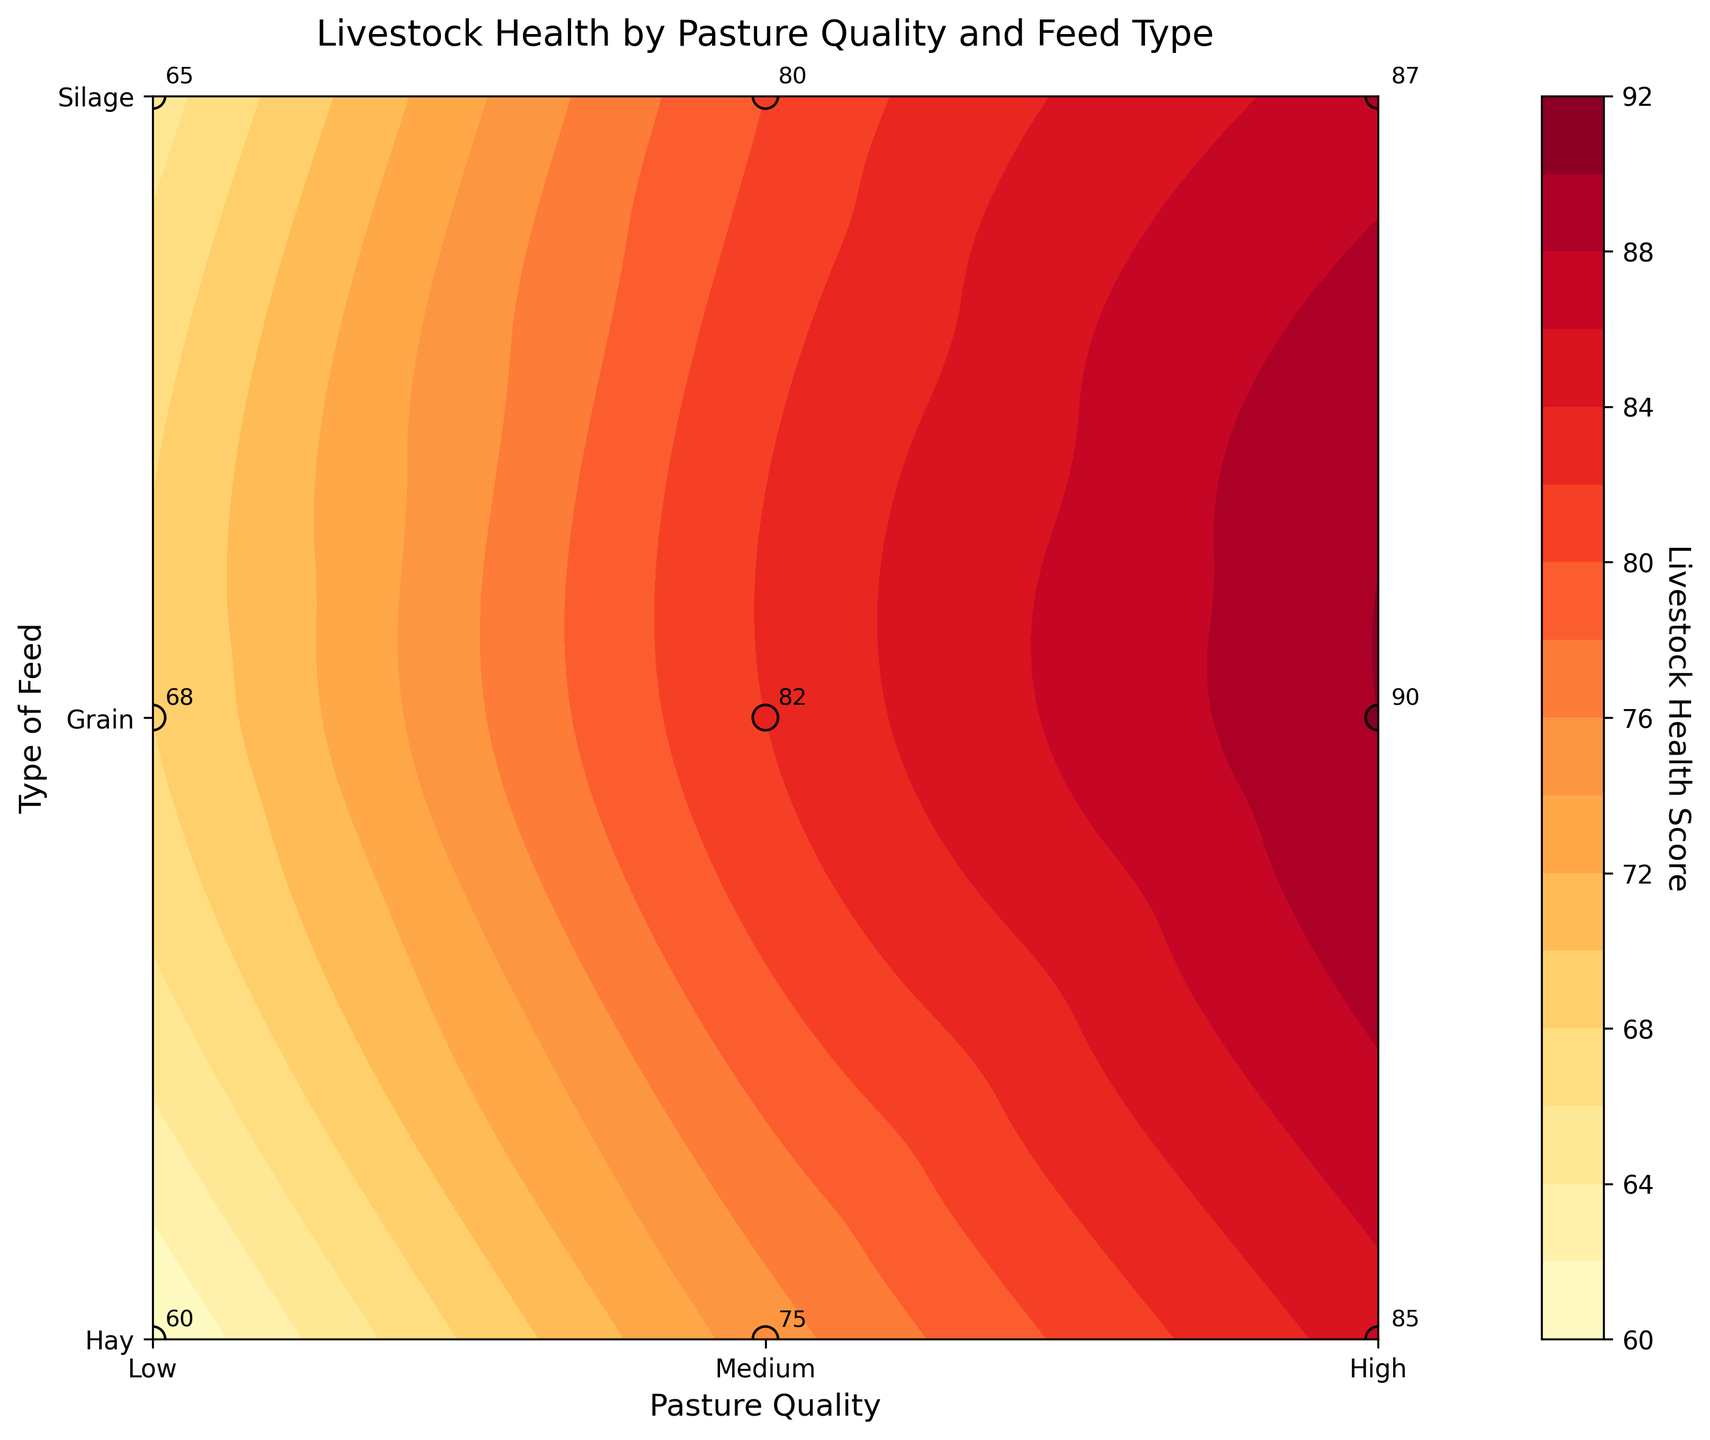What is the title of the figure? The title is located at the top of the figure. It provides a summary of what the figure is about.
Answer: Livestock Health by Pasture Quality and Feed Type Which axis represents the types of feed? The y-axis lists the types of feed used for the livestock.
Answer: Y-axis Which feed type and pasture quality combination achieved the highest livestock health score? The highest score is marked with the darkest color on the color gradient and is annotated with the value on the plot. The score for "High" pasture quality and "Grain" feed is 90, which is the highest.
Answer: High pasture quality and Grain feed What is the livestock health score for Medium pasture quality and Hay feed? Find the point where "Medium" pasture quality intersects with "Hay" feed, and read the annotated score value.
Answer: 75 Which pasture quality category has the highest average livestock health score across all feed types? Calculate the average score for "Low," "Medium," and "High" pasture qualities. "Low" has (60+68+65)/3=64.33, "Medium" has (75+82+80)/3=79, "High" has (85+90+87)/3=87.33.
Answer: High Between Silage and Hay feed types, which one performs better for Medium pasture quality? Compare the health scores for "Medium" pasture quality for "Silage" (80) and "Hay" (75) feed.
Answer: Silage How does livestock health score change from Low to High pasture quality when using Grain feed? Identify the scores for Grain feed in "Low" (68), "Medium" (82), and "High" (90) pasture qualities, and observe the trend.
Answer: It increases What is the lowest livestock health score shown in the figure? The lowest score can be found by identifying the lightest color on the gradient and reading its value. The score for Low pasture quality and Hay feed is 60, which is the lowest.
Answer: 60 Which feed type shows more variation in livestock health scores across different pasture qualities? Look at the range of scores for each feed type: Hay (60-85), Grain (68-90), Silage (65-87). Compare the range of values (difference between max and min scores).
Answer: Grain 